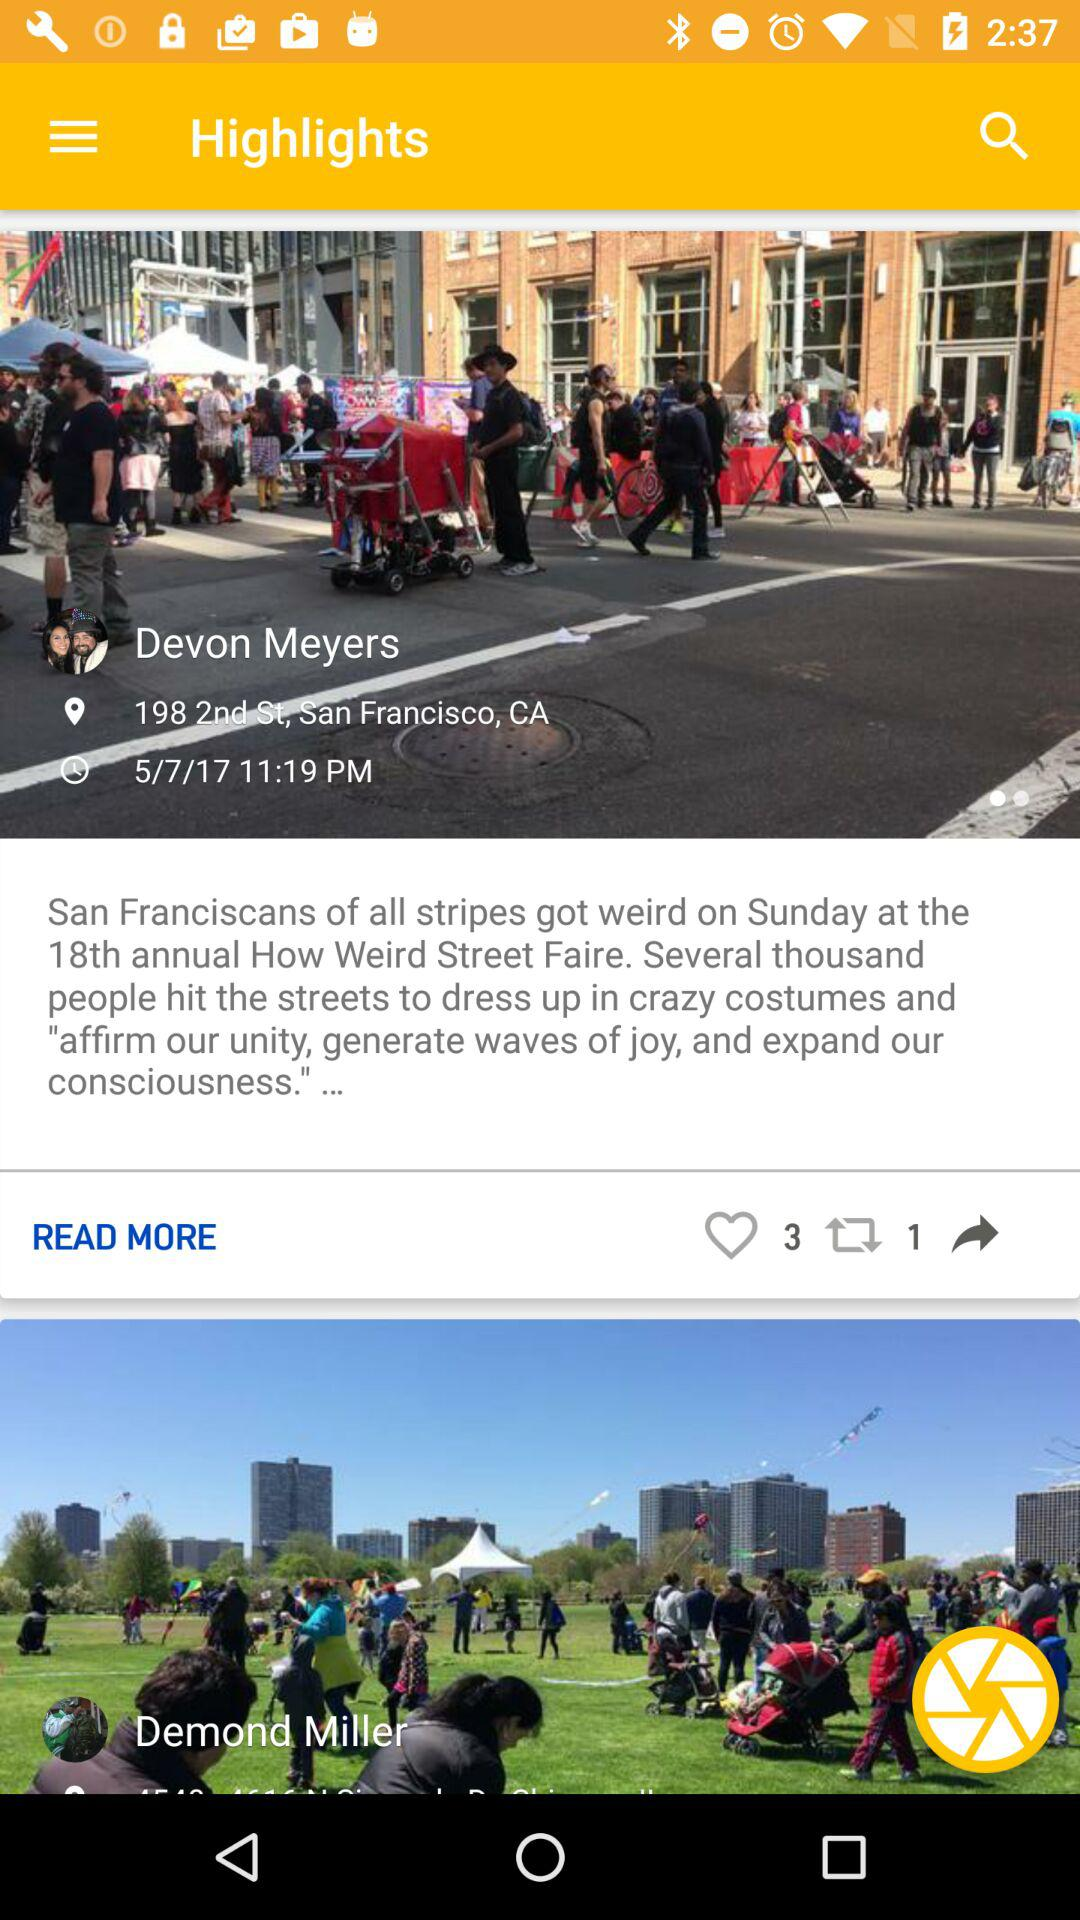How many items have a picture of a person?
Answer the question using a single word or phrase. 2 